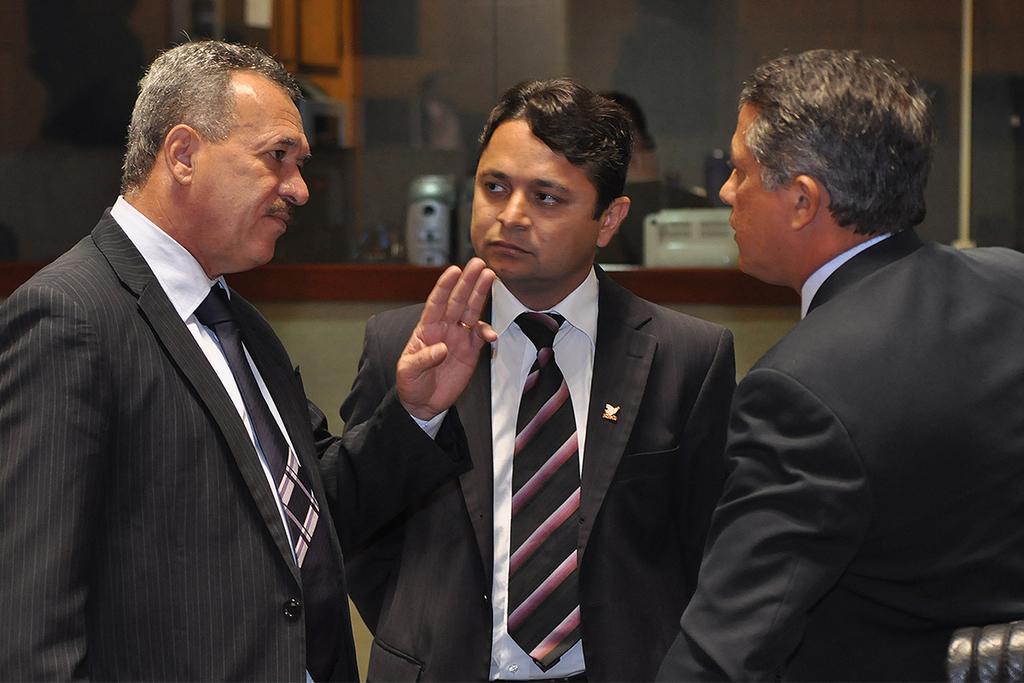How would you summarize this image in a sentence or two? In this picture there are three persons standing. At the back there is a person and there are objects and there are might be framed on the wall. 